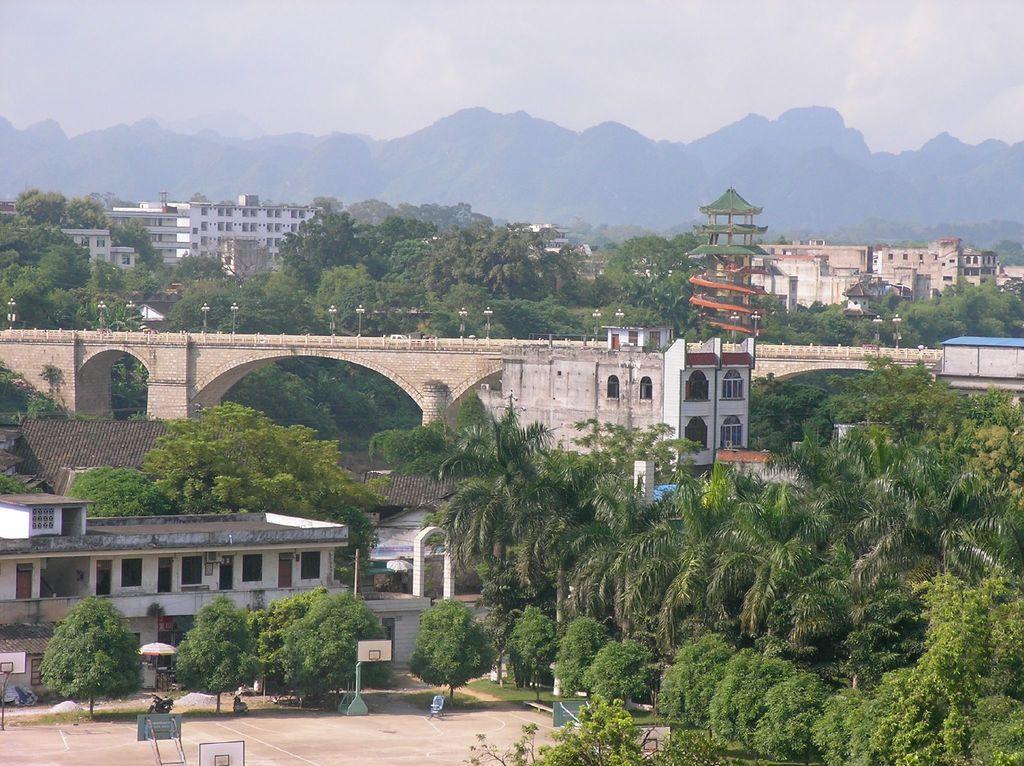Can you describe this image briefly? In this picture we can see buildings with windows, trees, mountains and in the background we can see the sky with clouds. 